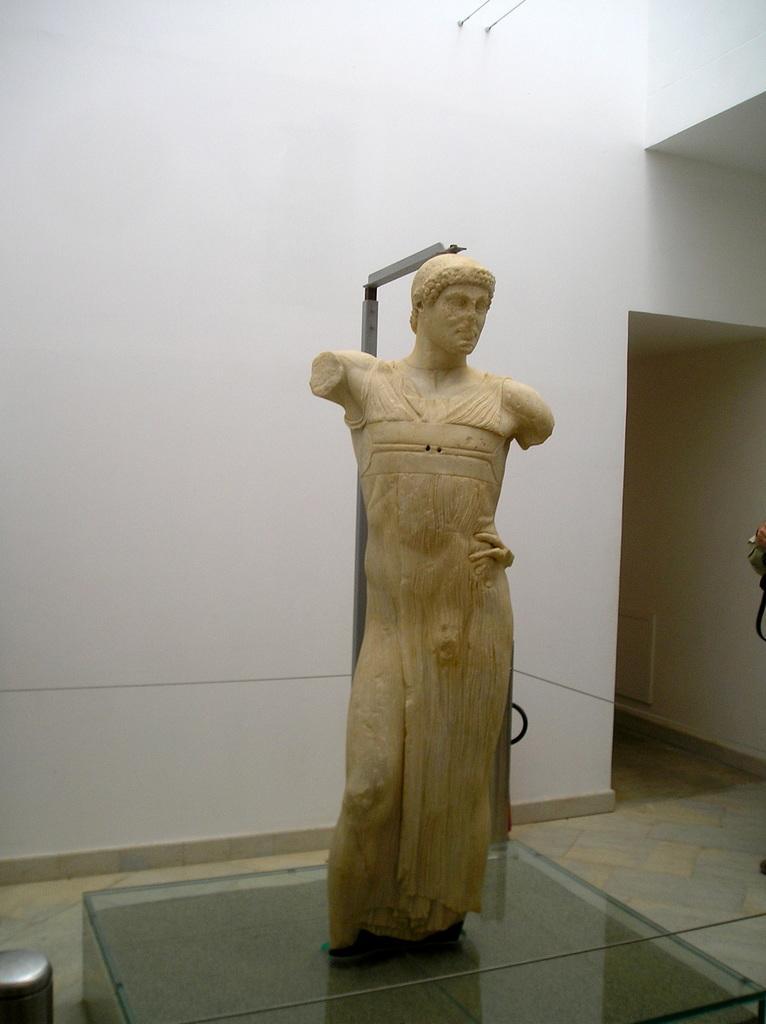Describe this image in one or two sentences. In this image we can see a sculpture on the glass surface and also we can see a pole and the wall. 